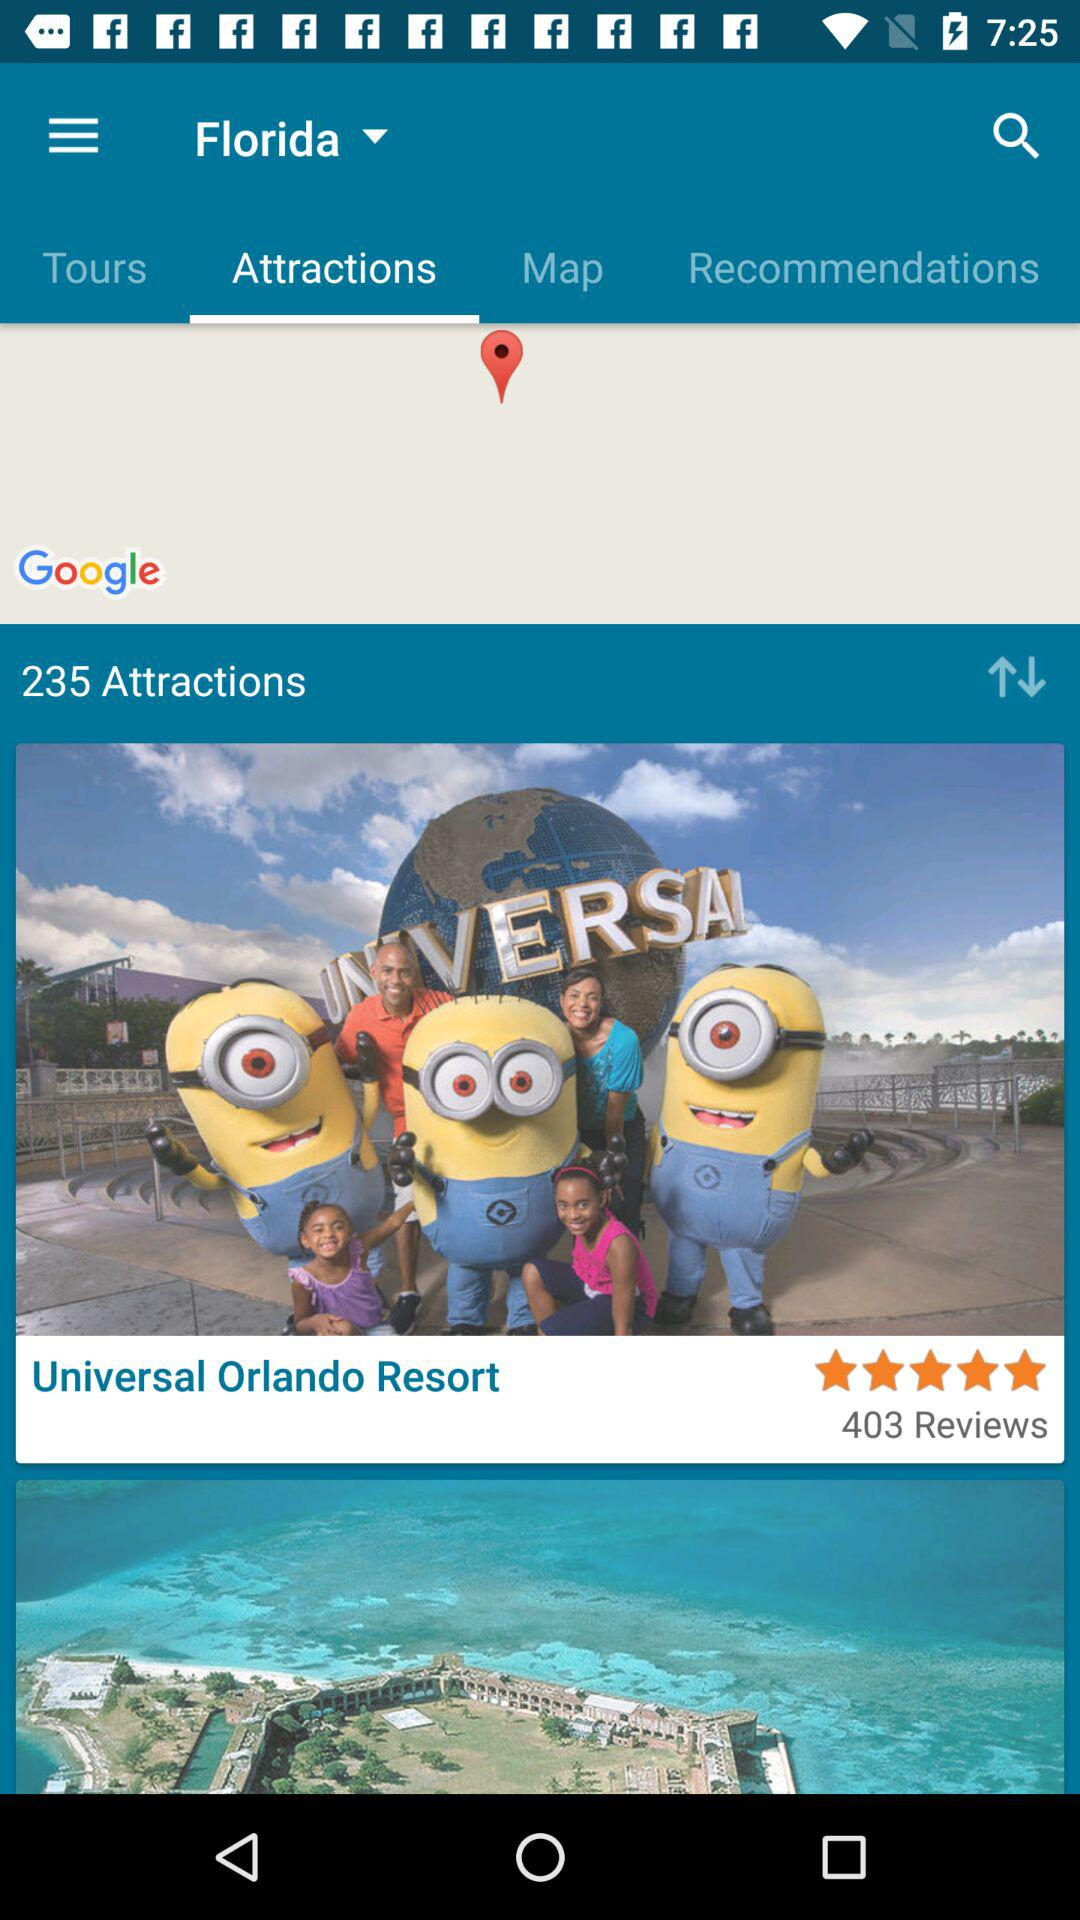How many attractions are there?
Answer the question using a single word or phrase. 235 